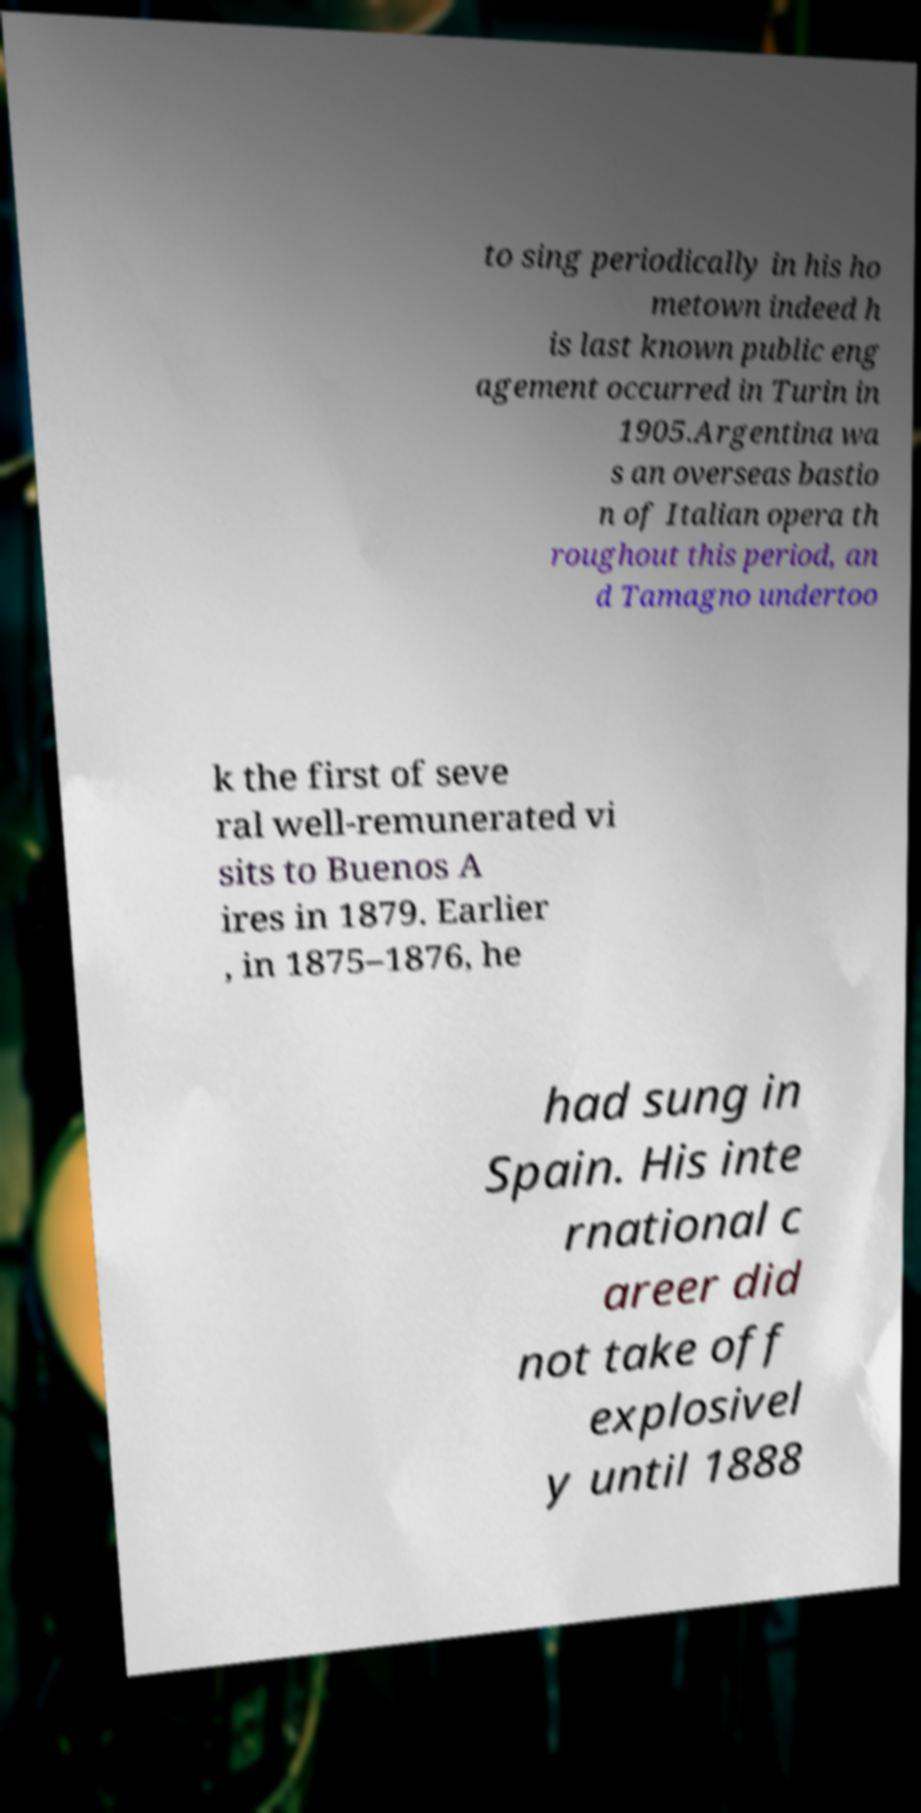What messages or text are displayed in this image? I need them in a readable, typed format. to sing periodically in his ho metown indeed h is last known public eng agement occurred in Turin in 1905.Argentina wa s an overseas bastio n of Italian opera th roughout this period, an d Tamagno undertoo k the first of seve ral well-remunerated vi sits to Buenos A ires in 1879. Earlier , in 1875–1876, he had sung in Spain. His inte rnational c areer did not take off explosivel y until 1888 